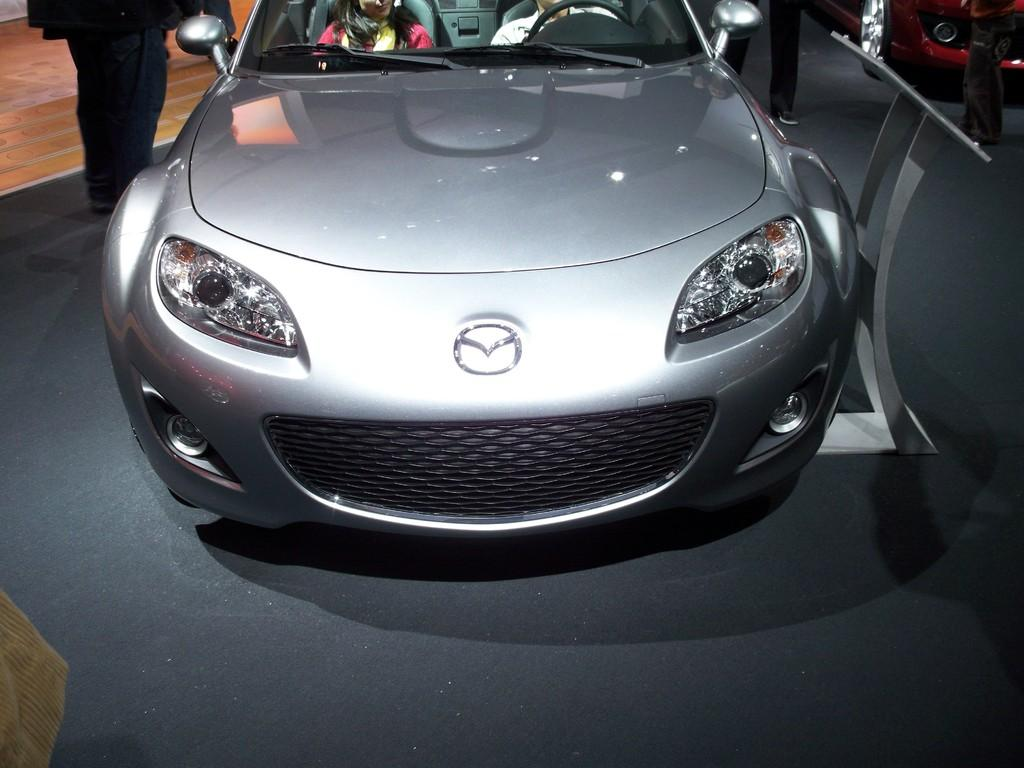What is placed on the floor in the image? There is a car on the floor in the image. How many people are sitting in the car? Two people are sitting in the car. What can be seen in the image besides the car and people? There is a stand in the image. What type of object is the car in the image? There is a vehicle in the image. Can you describe the people present in the image? There are people present in the image. What type of advertisement can be seen on the car in the image? There is no advertisement visible on the car in the image. Can you compare the size of the car to a dinosaur in the image? There are no dinosaurs present in the image, so it is not possible to make a comparison. 